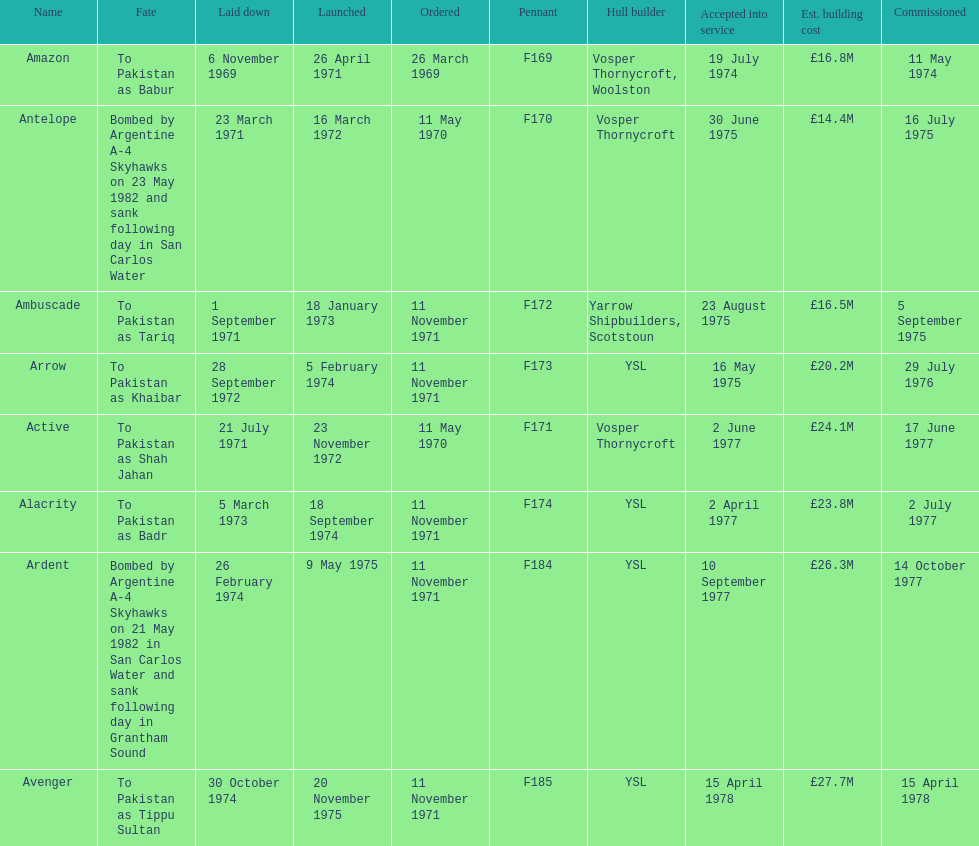Can you provide the name of the ship that is listed after ardent? Avenger. 